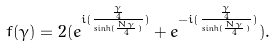Convert formula to latex. <formula><loc_0><loc_0><loc_500><loc_500>f ( \gamma ) = 2 ( e ^ { i ( \frac { \frac { \gamma } { 4 } } { \sinh ( \frac { N \gamma } { 4 } ) } ) } + e ^ { - i ( \frac { \frac { \gamma } { 4 } } { \sinh ( \frac { N \gamma } { 4 } ) } ) } ) .</formula> 